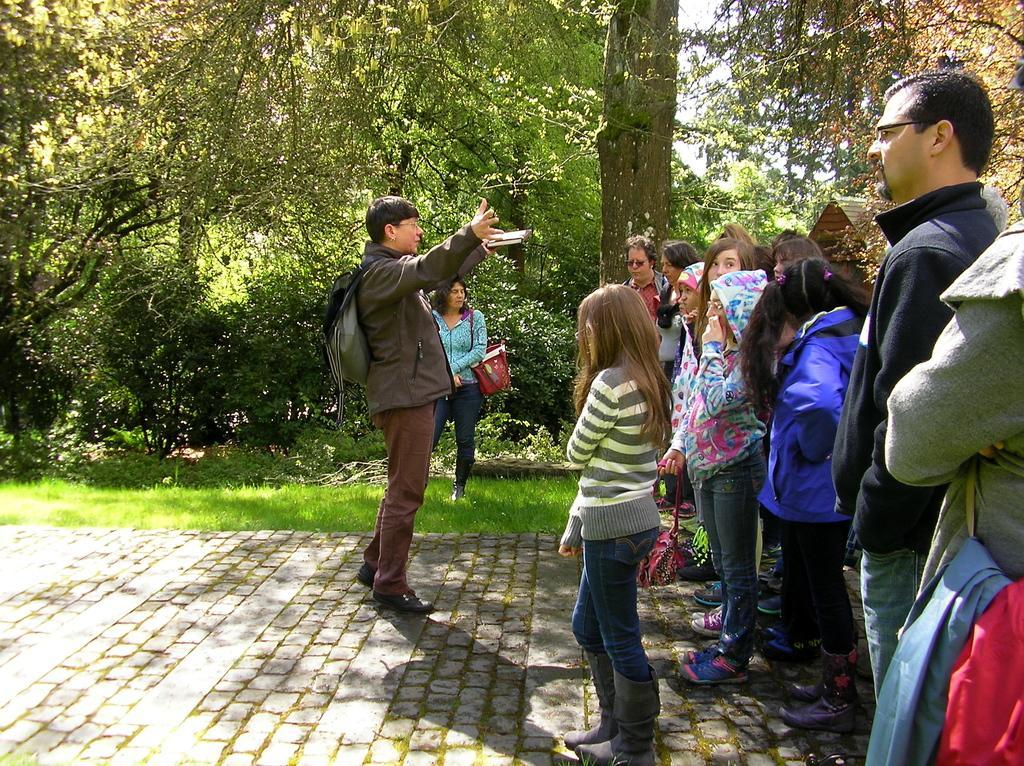How would you summarize this image in a sentence or two? In this image we can see few people standing on the pavement, some of them are carrying bags, there are some plants, trees, grass, also we can see the sky. 